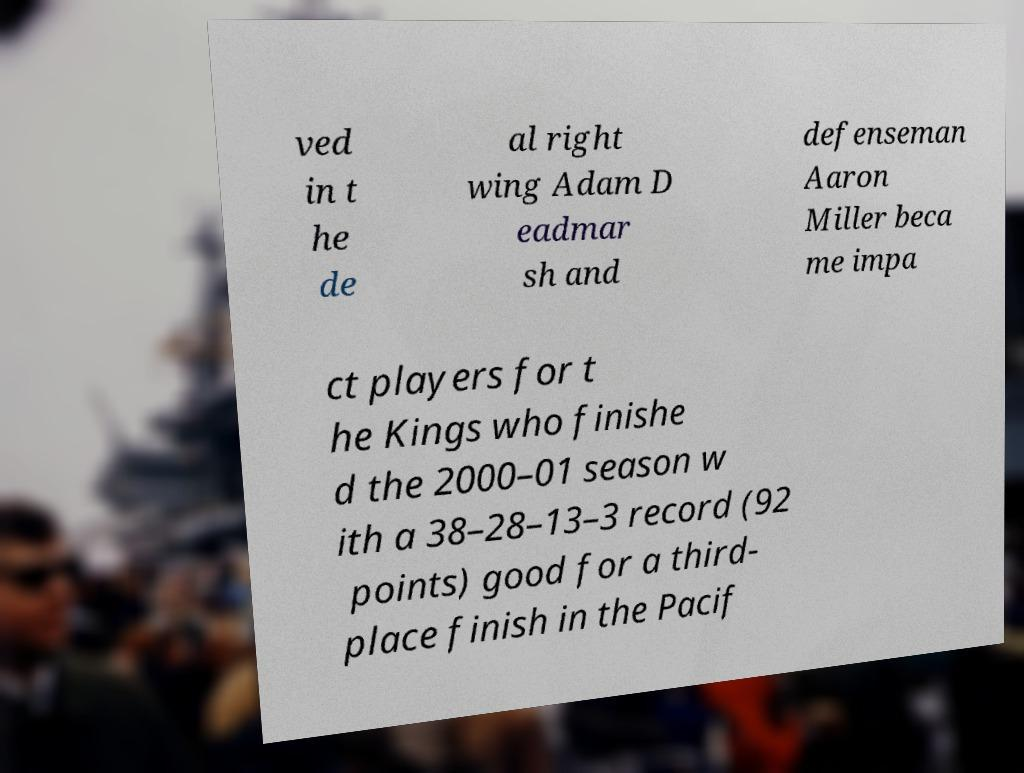Please identify and transcribe the text found in this image. ved in t he de al right wing Adam D eadmar sh and defenseman Aaron Miller beca me impa ct players for t he Kings who finishe d the 2000–01 season w ith a 38–28–13–3 record (92 points) good for a third- place finish in the Pacif 